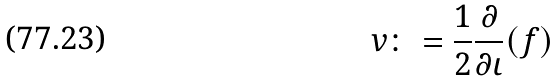Convert formula to latex. <formula><loc_0><loc_0><loc_500><loc_500>v \colon = \frac { 1 } { 2 } \frac { \partial } { \partial \iota } ( f )</formula> 